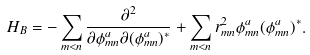Convert formula to latex. <formula><loc_0><loc_0><loc_500><loc_500>H _ { B } = - \sum _ { m < n } \frac { \partial ^ { 2 } } { \partial \phi _ { m n } ^ { a } \partial ( \phi _ { m n } ^ { a } ) ^ { * } } + \sum _ { m < n } r _ { m n } ^ { 2 } \phi _ { m n } ^ { a } ( \phi _ { m n } ^ { a } ) ^ { * } .</formula> 